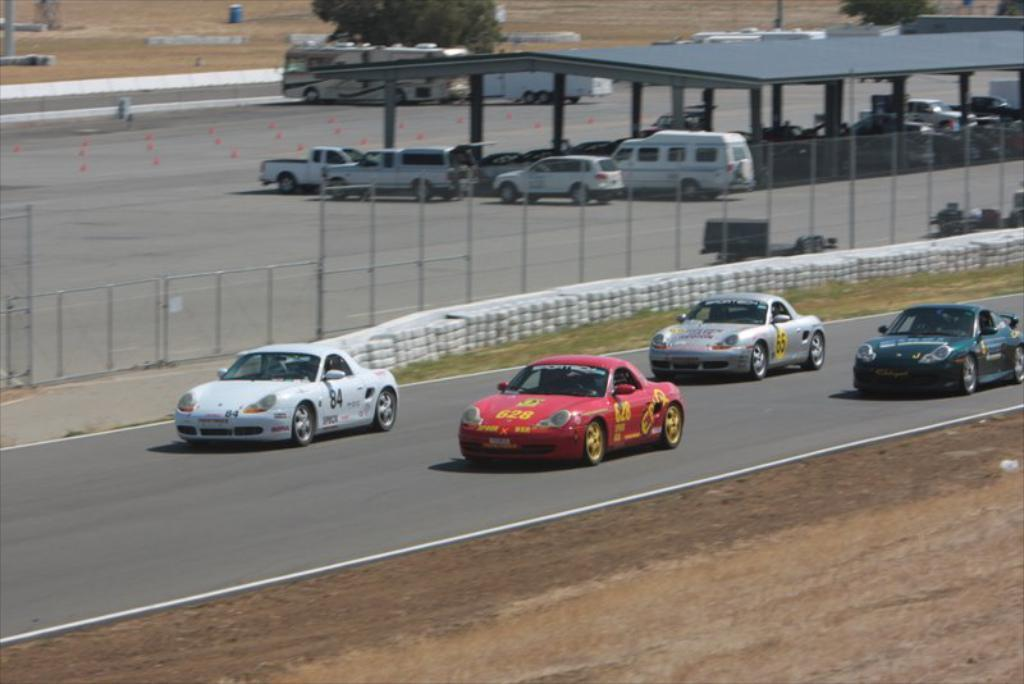Where was the picture taken? The picture was taken outside. What can be seen in the center of the image? There is a group of vehicles in the center of the image. What type of material is present in the image? There is a mesh and metal rods in the image. What type of natural environment is visible in the image? Grass is visible in the image. What type of structure is present in the image? There is a shed in the image. What type of vegetation is present in the image? Trees are present in the image. What type of riddle is being solved by the group of vehicles in the image? There is no riddle being solved by the group of vehicles in the image; they are simply parked or stationary. Is there a baseball game taking place in the image? There is no indication of a baseball game or any sports activity in the image. 